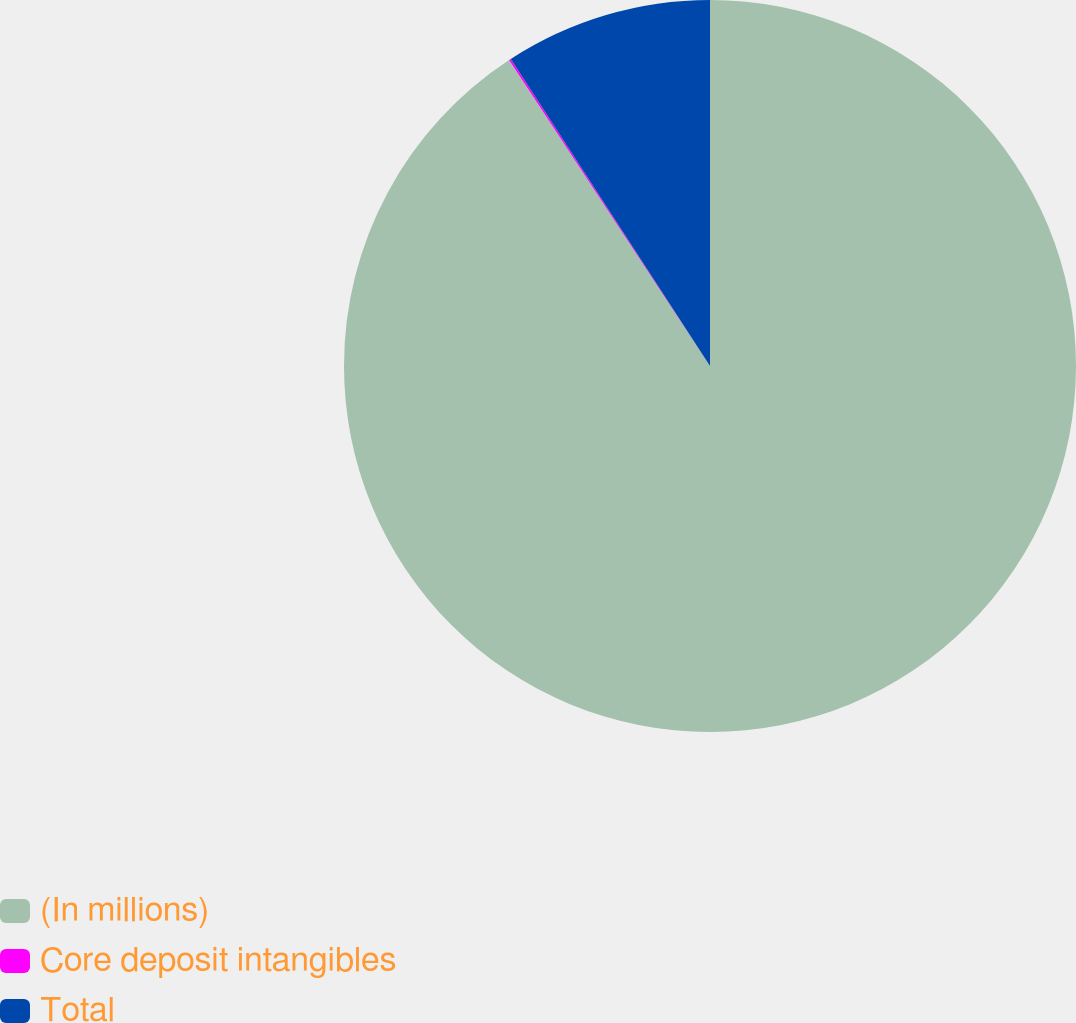<chart> <loc_0><loc_0><loc_500><loc_500><pie_chart><fcel>(In millions)<fcel>Core deposit intangibles<fcel>Total<nl><fcel>90.75%<fcel>0.09%<fcel>9.16%<nl></chart> 